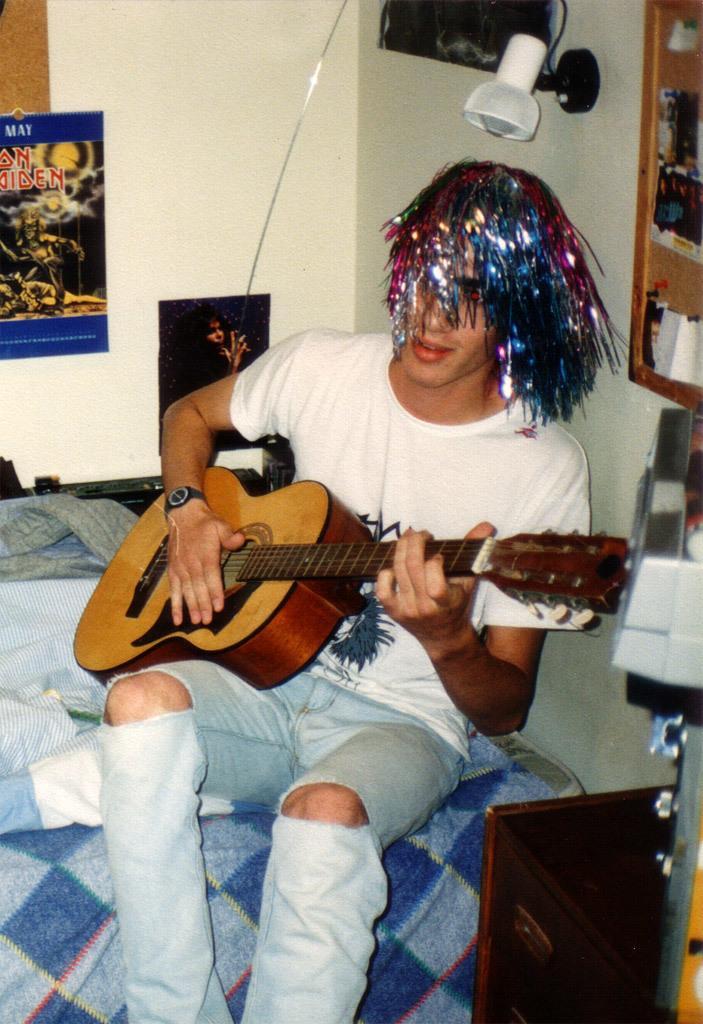How would you summarize this image in a sentence or two? In this image I can see a person sitting on the bed and holding the guitar. In the back there are frames and a lamp to the wall. 